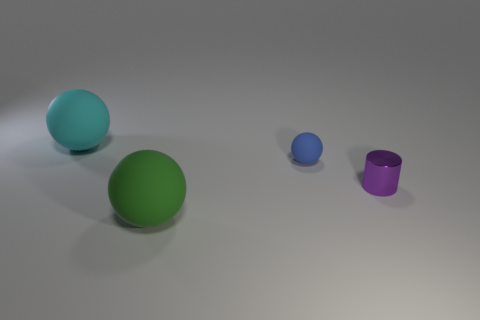Subtract all green matte balls. How many balls are left? 2 Subtract all cyan spheres. How many spheres are left? 2 Subtract 1 balls. How many balls are left? 2 Subtract all cylinders. How many objects are left? 3 Subtract all purple cylinders. How many brown spheres are left? 0 Subtract all small purple metal objects. Subtract all cyan rubber things. How many objects are left? 2 Add 3 green things. How many green things are left? 4 Add 1 blue matte things. How many blue matte things exist? 2 Add 1 large green objects. How many objects exist? 5 Subtract 0 yellow spheres. How many objects are left? 4 